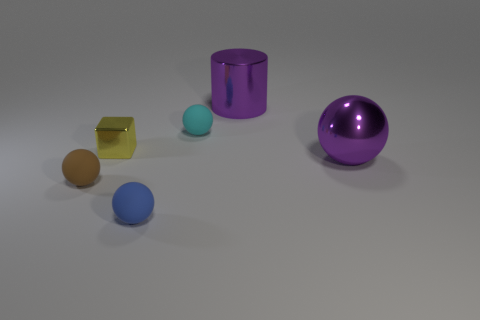Subtract 1 balls. How many balls are left? 3 Add 4 tiny blue spheres. How many objects exist? 10 Subtract all cylinders. How many objects are left? 5 Subtract all spheres. Subtract all tiny cubes. How many objects are left? 1 Add 2 yellow metallic things. How many yellow metallic things are left? 3 Add 4 big brown matte cylinders. How many big brown matte cylinders exist? 4 Subtract 0 red cylinders. How many objects are left? 6 